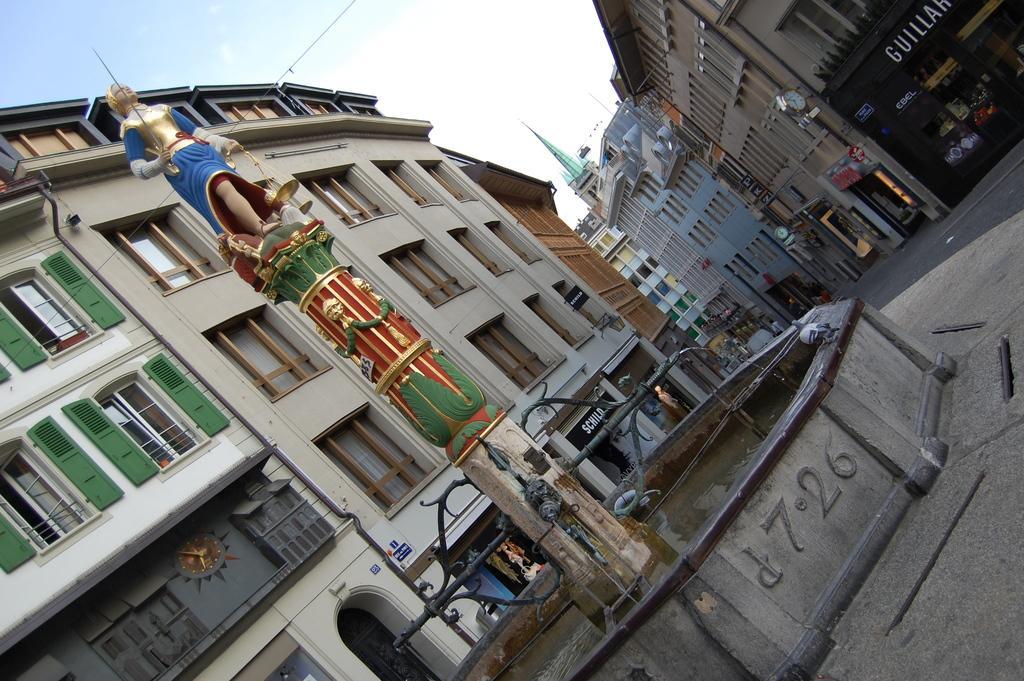In one or two sentences, can you explain what this image depicts? In this picture there is a fountain at the bottom. In between the fountain there is a statue holding a weapon. In the background there are buildings with windows and doors. On the top left there is a sky. 